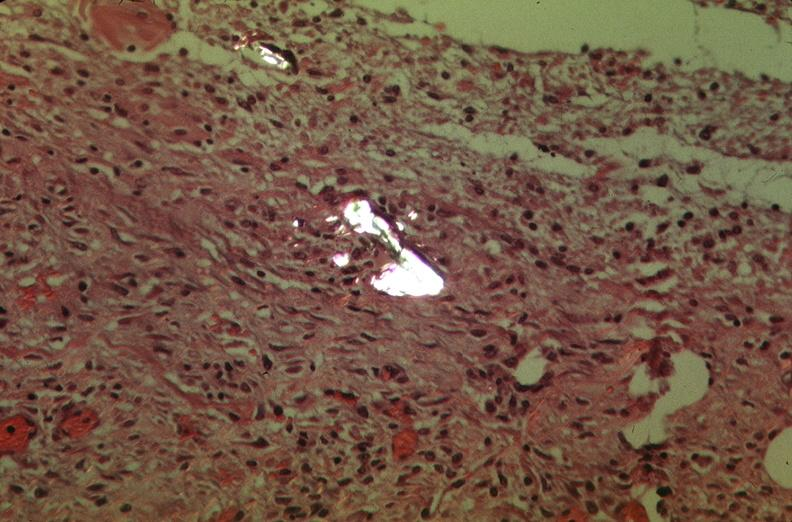does aorta show pleura, talc reaction showing talc birefringence?
Answer the question using a single word or phrase. No 